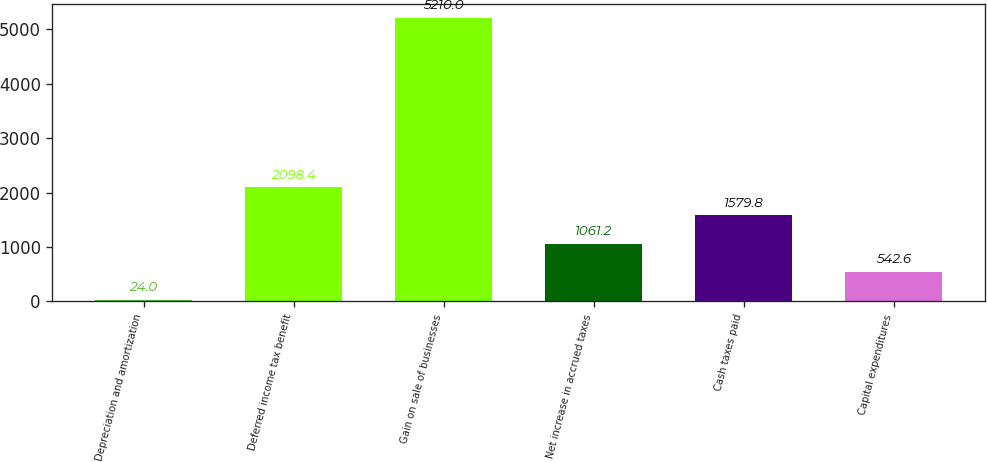Convert chart to OTSL. <chart><loc_0><loc_0><loc_500><loc_500><bar_chart><fcel>Depreciation and amortization<fcel>Deferred income tax benefit<fcel>Gain on sale of businesses<fcel>Net increase in accrued taxes<fcel>Cash taxes paid<fcel>Capital expenditures<nl><fcel>24<fcel>2098.4<fcel>5210<fcel>1061.2<fcel>1579.8<fcel>542.6<nl></chart> 